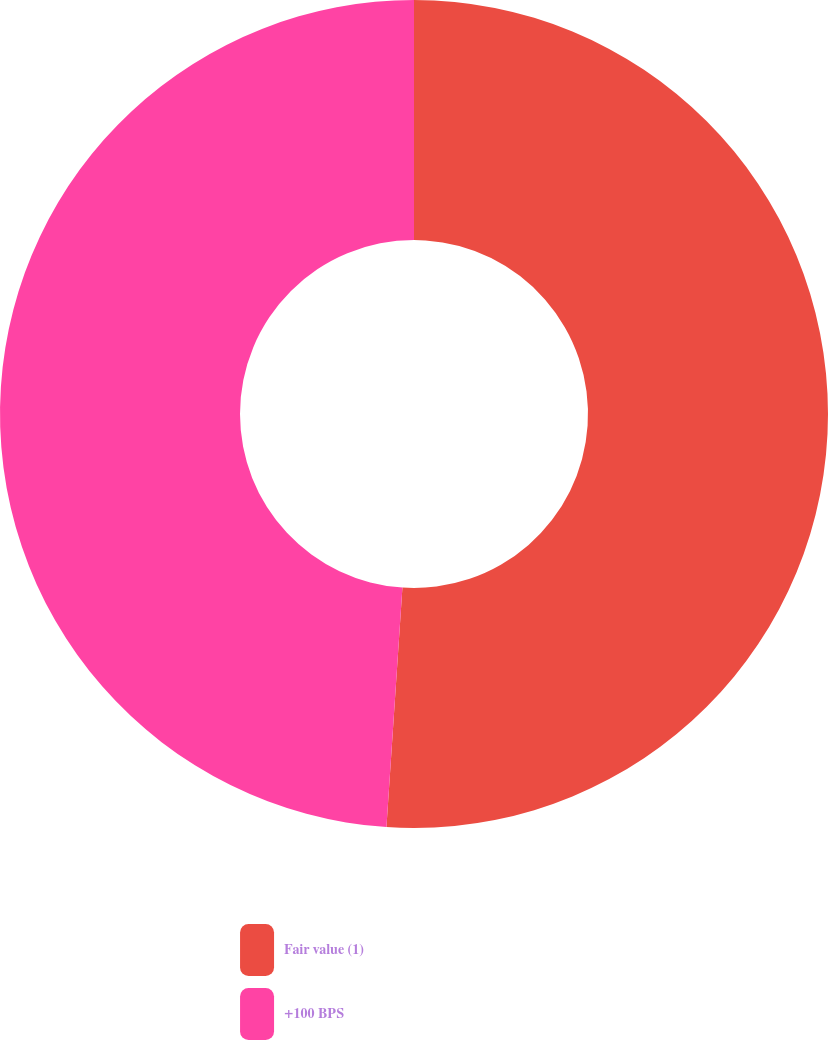Convert chart to OTSL. <chart><loc_0><loc_0><loc_500><loc_500><pie_chart><fcel>Fair value (1)<fcel>+100 BPS<nl><fcel>51.06%<fcel>48.94%<nl></chart> 